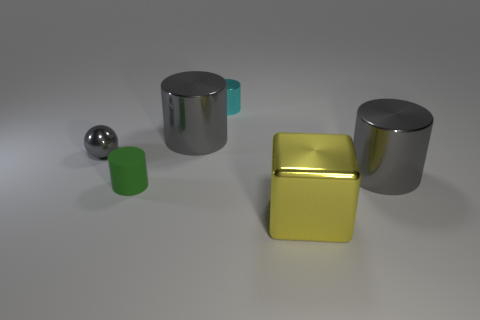How many objects are either metal objects that are right of the small metallic sphere or large red metallic blocks?
Ensure brevity in your answer.  4. What shape is the metal thing that is in front of the matte object?
Offer a terse response. Cube. Are there an equal number of metal balls that are in front of the tiny green matte thing and gray shiny spheres left of the yellow metal cube?
Provide a short and direct response. No. The cylinder that is in front of the small gray shiny thing and on the right side of the tiny green thing is what color?
Your answer should be very brief. Gray. What material is the gray cylinder that is behind the object that is on the right side of the shiny block?
Your response must be concise. Metal. Do the cyan cylinder and the sphere have the same size?
Make the answer very short. Yes. How many tiny objects are rubber cylinders or red things?
Your response must be concise. 1. What number of cubes are right of the small cyan metallic cylinder?
Offer a very short reply. 1. Is the number of yellow metal things in front of the cyan cylinder greater than the number of purple balls?
Ensure brevity in your answer.  Yes. What is the shape of the cyan thing that is made of the same material as the big block?
Offer a terse response. Cylinder. 